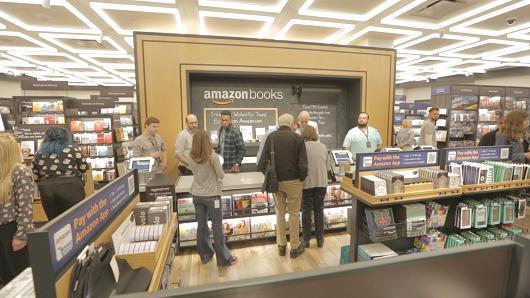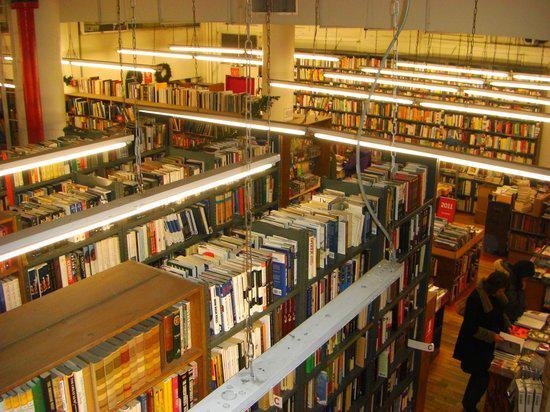The first image is the image on the left, the second image is the image on the right. For the images displayed, is the sentence "No one is visible in the bookstore in the left." factually correct? Answer yes or no. No. The first image is the image on the left, the second image is the image on the right. Evaluate the accuracy of this statement regarding the images: "Suspended non-tube-shaped lights are visible in at least one bookstore image.". Is it true? Answer yes or no. No. 